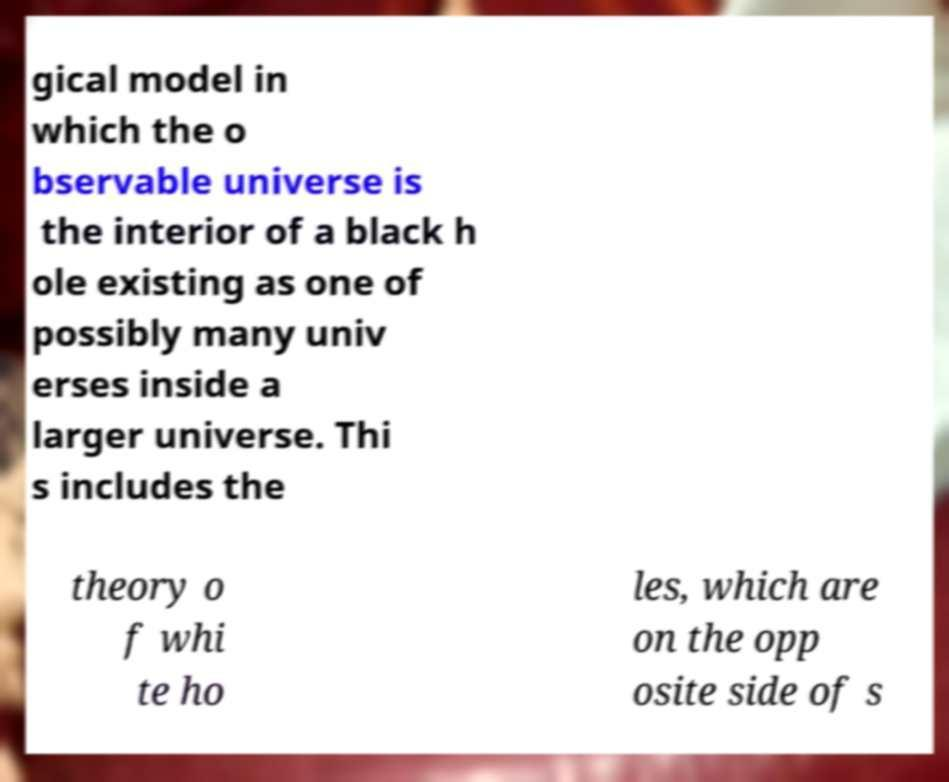Please identify and transcribe the text found in this image. gical model in which the o bservable universe is the interior of a black h ole existing as one of possibly many univ erses inside a larger universe. Thi s includes the theory o f whi te ho les, which are on the opp osite side of s 